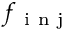<formula> <loc_0><loc_0><loc_500><loc_500>f _ { i n j }</formula> 